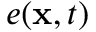Convert formula to latex. <formula><loc_0><loc_0><loc_500><loc_500>e ( x , t )</formula> 